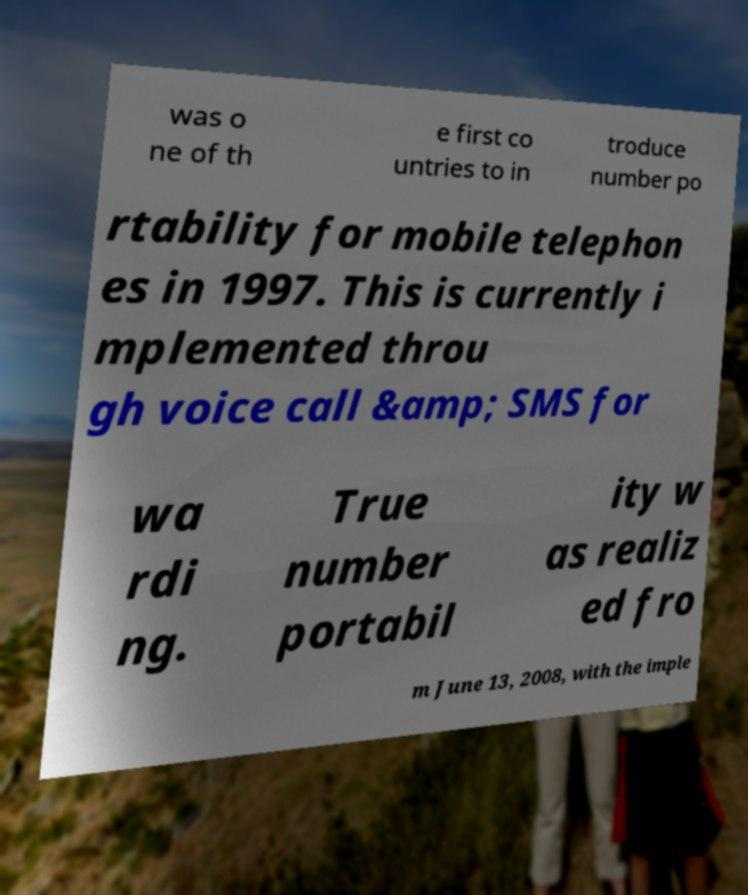Can you read and provide the text displayed in the image?This photo seems to have some interesting text. Can you extract and type it out for me? was o ne of th e first co untries to in troduce number po rtability for mobile telephon es in 1997. This is currently i mplemented throu gh voice call &amp; SMS for wa rdi ng. True number portabil ity w as realiz ed fro m June 13, 2008, with the imple 